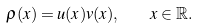Convert formula to latex. <formula><loc_0><loc_0><loc_500><loc_500>\rho ( x ) = u ( x ) v ( x ) , \quad x \in \mathbb { R } .</formula> 